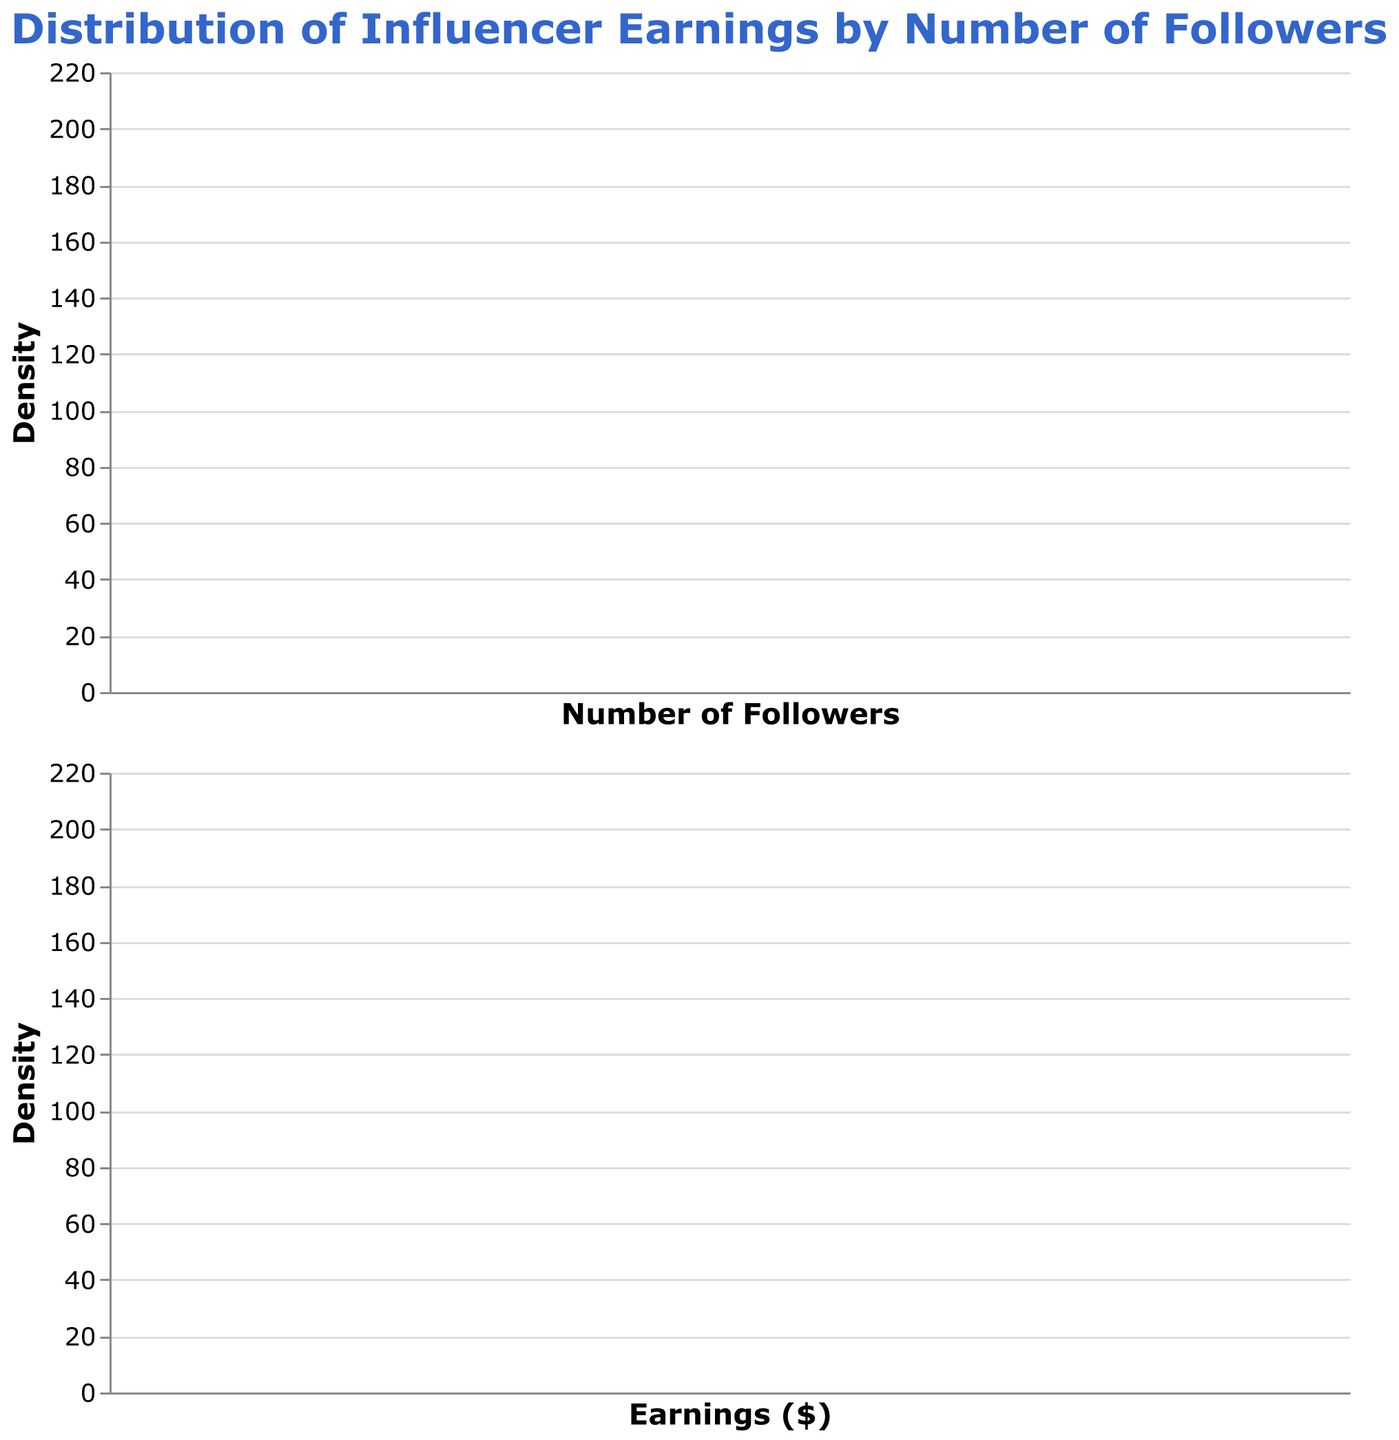What is the title of the figure? The title is displayed at the top of the figure and reads "Distribution of Influencer Earnings by Number of Followers".
Answer: Distribution of Influencer Earnings by Number of Followers What is the color of the 'Followers' density plot? The 'Followers' density plot is filled with a pinkish color, described as "#ff9999" in code, but visually it appears as light pink.
Answer: Light pink Which axis represents the 'Number of Followers'? The axis representing the 'Number of Followers' is the horizontal (x) axis in the first subplot. This can be observed in the label "Number of Followers" below the axis.
Answer: Horizontal axis How many density plots are shown in the figure? There are two density plots shown in the figure, one for 'Number of Followers' and another for 'Earnings'. This is observed from the two distinct plots with different x-axis labels.
Answer: Two Which axis represents 'Earnings ($)'? The axis representing 'Earnings ($)' is the horizontal (x) axis in the second subplot. This is shown by the label "Earnings ($)" below the axis.
Answer: Horizontal axis Between Followers and Earnings, which one appears to have a more spread-out distribution? Comparing the spread of densities in the two plots, the one with 'Number of Followers' has more spread-out values evident from its broader area, while the 'Earnings' have a narrower density distribution.
Answer: Followers In general, do influencers with more followers make more earnings? Observing the distributions, we can see that influencers with higher follower counts in the first plot tend to align with higher earnings in the second plot, though overlapping ranges suggest variability.
Answer: Generally, yes What is the density peak range for Followers? The peak range for the 'Followers' density, where the density is highest, appears to be around 10 million to 20 million followers based on the curve's peak in the first plot.
Answer: 10 million to 20 million Are there any influencers with low followers but high earnings? Checking the peaks of both plots, there are instances where influencers with around 10 million followers align with higher earnings above $70,000, suggesting some low follower counts but relatively high earnings.
Answer: Yes Which density plot has less variance? The 'Earnings' density plot has less variance as the spread of the curve is narrower compared to the 'Followers' plot indicating less variability in earnings distribution.
Answer: Earnings 